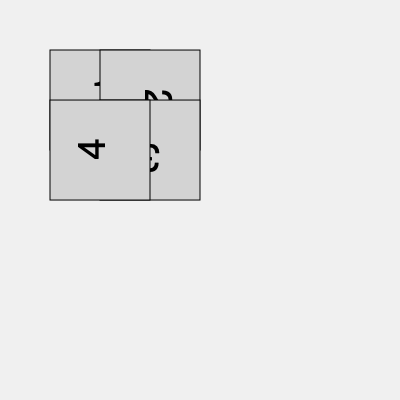As a conservative politician tasked with preserving the integrity of our constitution, you must mentally rotate and align these pieces to form a complete document. Which piece should be rotated 180 degrees to ensure the constitution is properly assembled? To solve this problem, we need to mentally rotate each piece and determine which one requires a 180-degree rotation to form a complete square document:

1. Piece 1 is already in the correct position (top-left corner).
2. Piece 2 is rotated 90 degrees clockwise and should be in the top-right corner.
3. Piece 3 is upside down (rotated 180 degrees) and should be in the bottom-right corner.
4. Piece 4 is rotated 90 degrees counterclockwise and should be in the bottom-left corner.

By examining each piece, we can see that Piece 3 is the only one that needs to be rotated 180 degrees to be in its correct orientation. This rotation will ensure that all pieces align properly to form a complete, readable constitution document.
Answer: Piece 3 